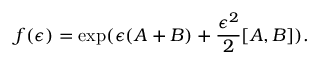<formula> <loc_0><loc_0><loc_500><loc_500>f ( \epsilon ) = \exp ( \epsilon ( A + B ) + \frac { \epsilon ^ { 2 } } { 2 } [ A , B ] ) .</formula> 